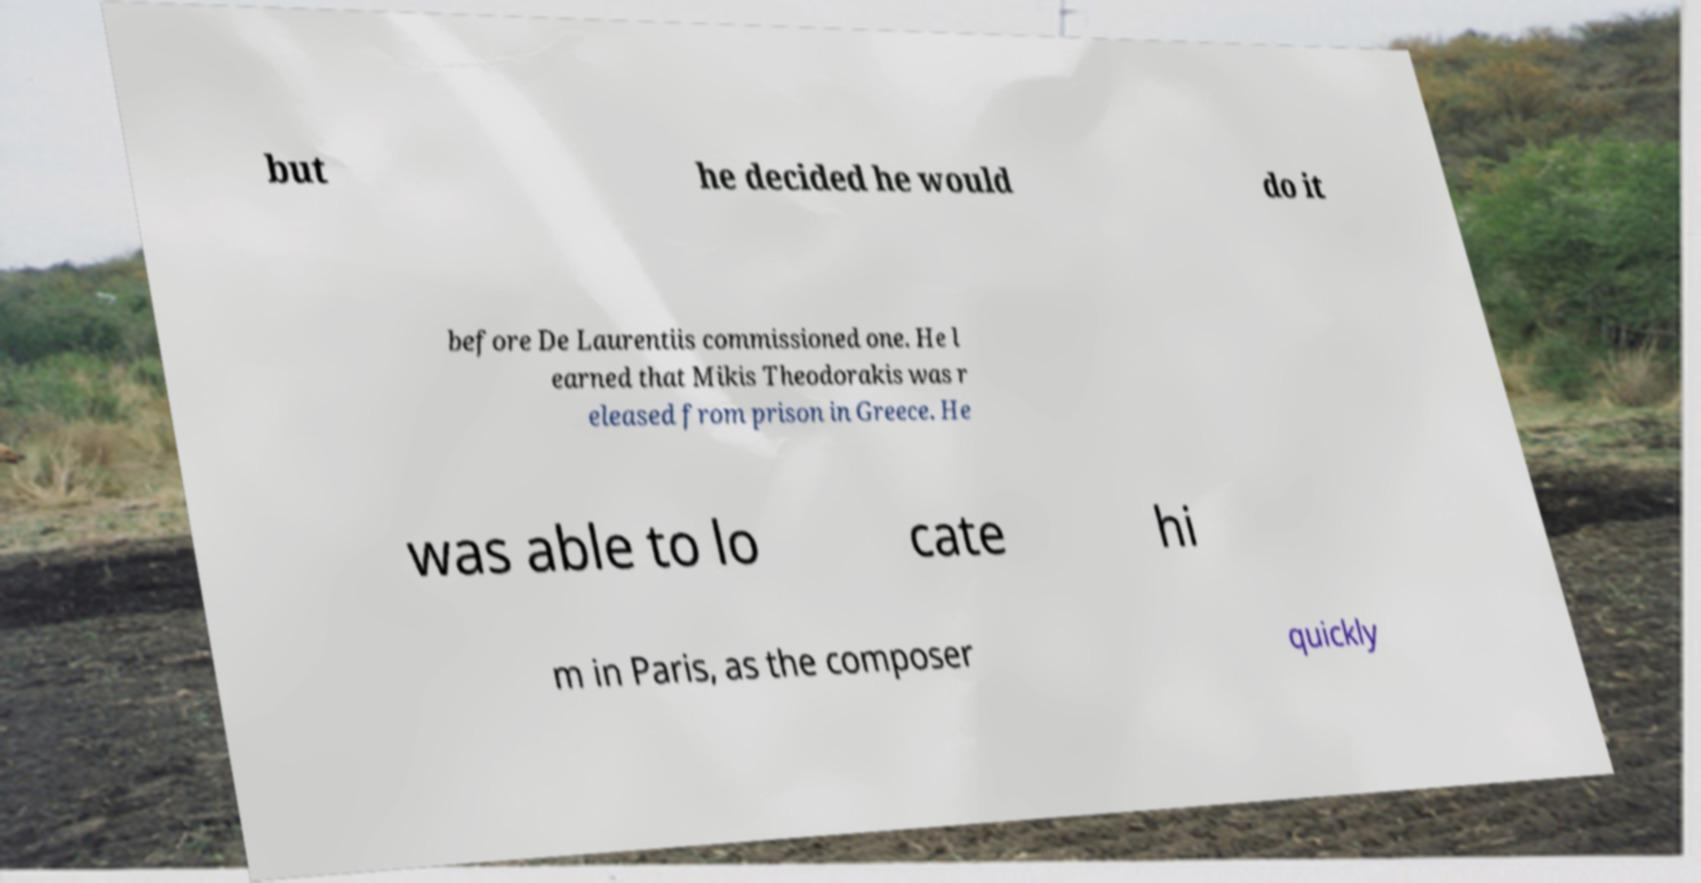Could you extract and type out the text from this image? but he decided he would do it before De Laurentiis commissioned one. He l earned that Mikis Theodorakis was r eleased from prison in Greece. He was able to lo cate hi m in Paris, as the composer quickly 